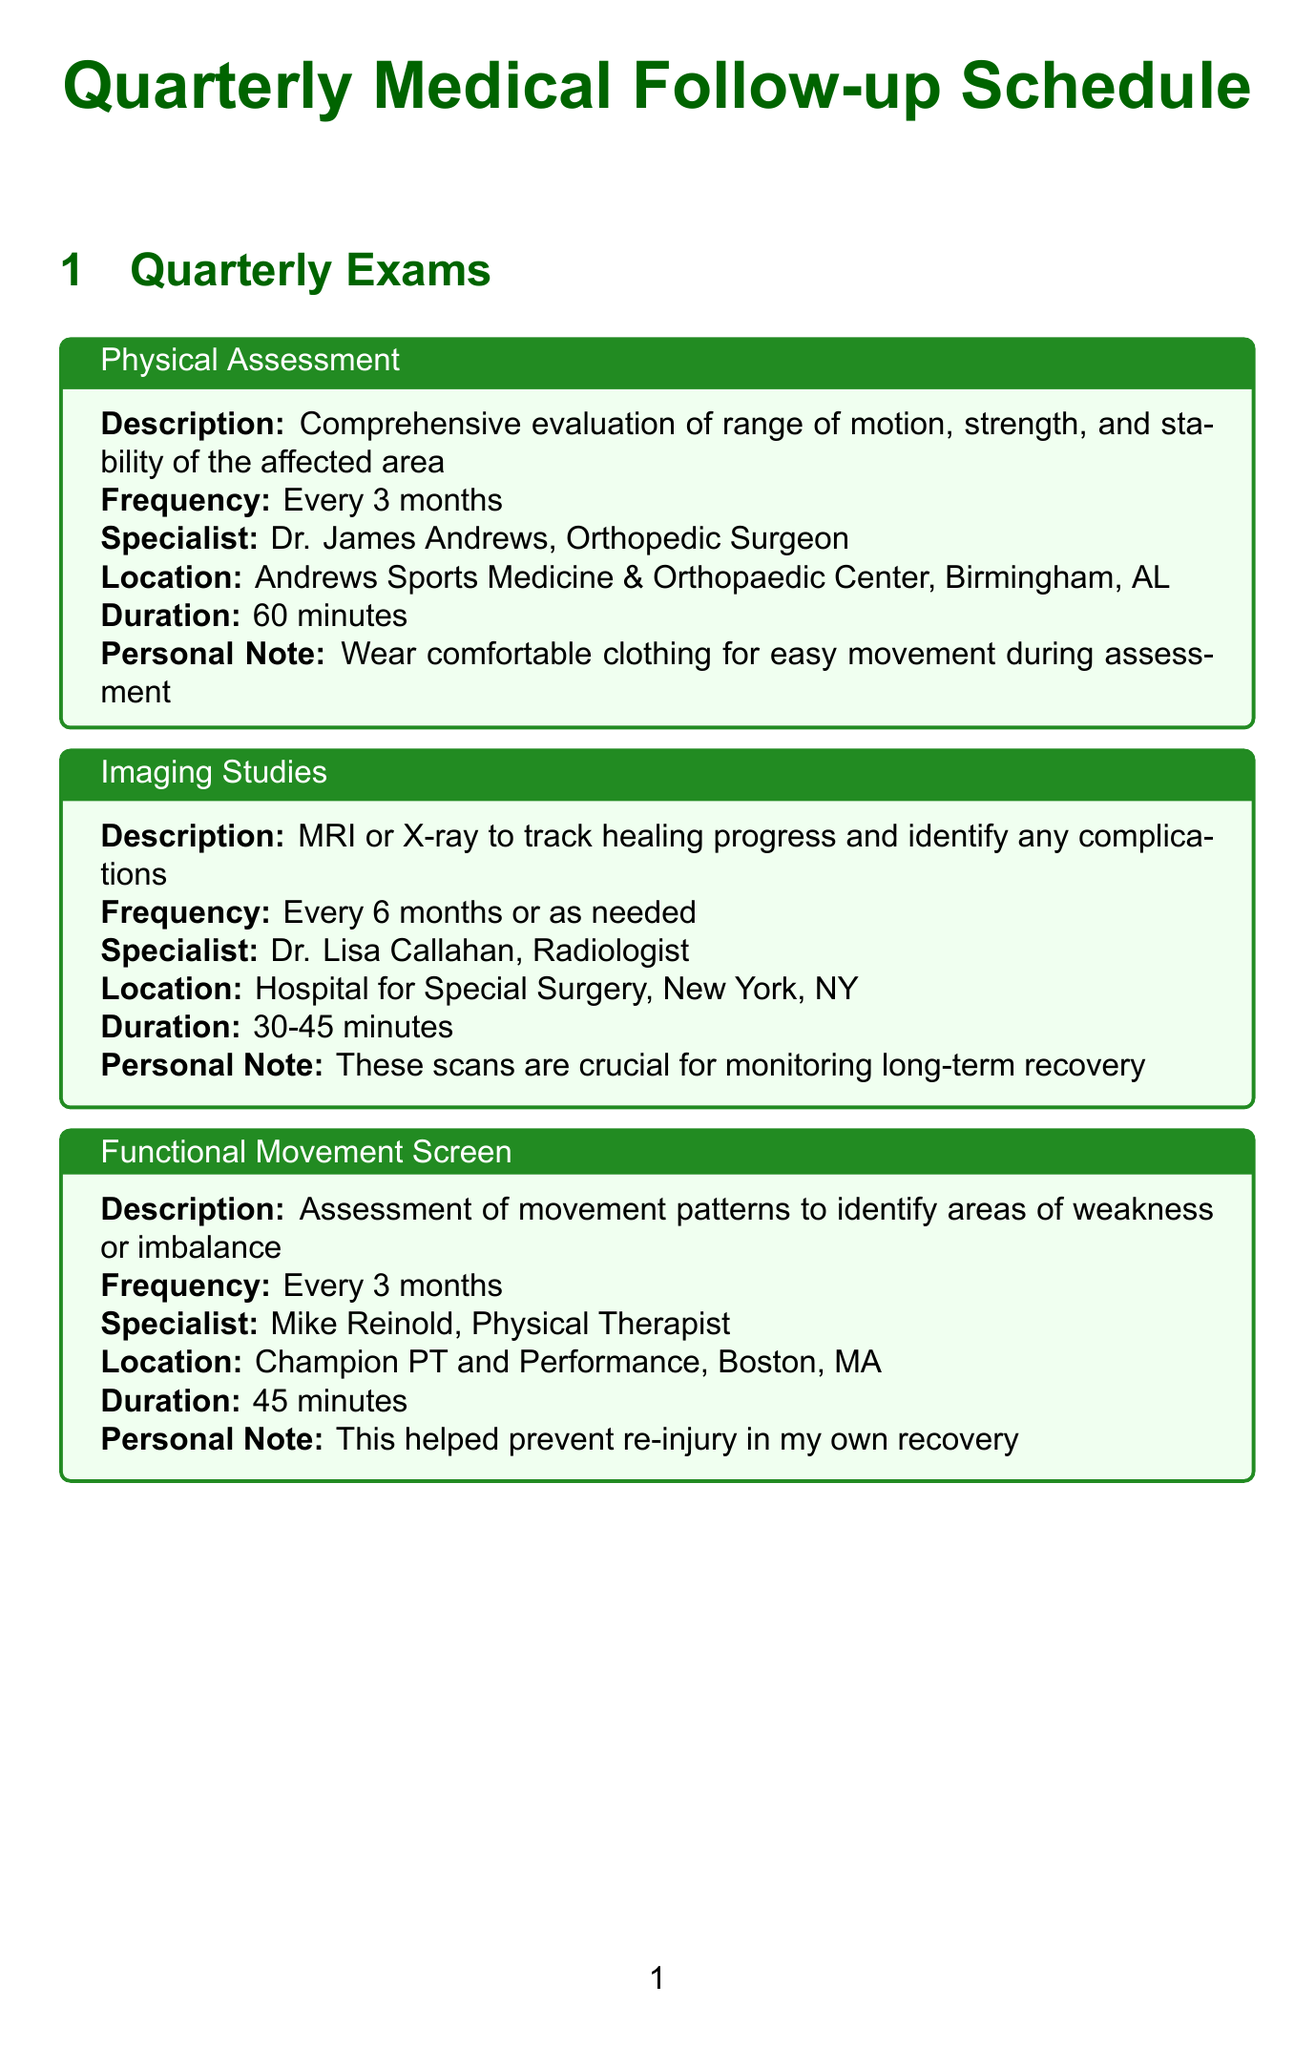What is the frequency of the Physical Assessment? The frequency of the Physical Assessment is stated as every 3 months.
Answer: Every 3 months Who conducts the Imaging Studies? The Imaging Studies are conducted by Dr. Lisa Callahan, as mentioned in the document.
Answer: Dr. Lisa Callahan How many metrics are evaluated in the Injury Site Progress Report? The document lists three metrics for the Injury Site Progress Report: Pain levels, Inflammation, and Tissue healing.
Answer: 3 What is the duration of the Strength and Conditioning Evaluation? The duration of the Strength and Conditioning Evaluation is provided as 90 minutes in the document.
Answer: 90 minutes Which evaluation is conducted monthly? The document specifies that the Range of Motion Analysis is conducted monthly.
Answer: Range of Motion Analysis What is the location for the Functional Movement Screen? The location for the Functional Movement Screen is Champion PT and Performance, Boston, MA, as stated in the document.
Answer: Champion PT and Performance, Boston, MA What personal note is associated with the Mental Health Check-up? The personal note associated with the Mental Health Check-up emphasizes sharing personal experiences with mental challenges.
Answer: Share personal experiences with mental challenges during injury recovery How often should the Nutritional Assessment be performed? According to the document, the Nutritional Assessment should be performed every 6 months.
Answer: Every 6 months 